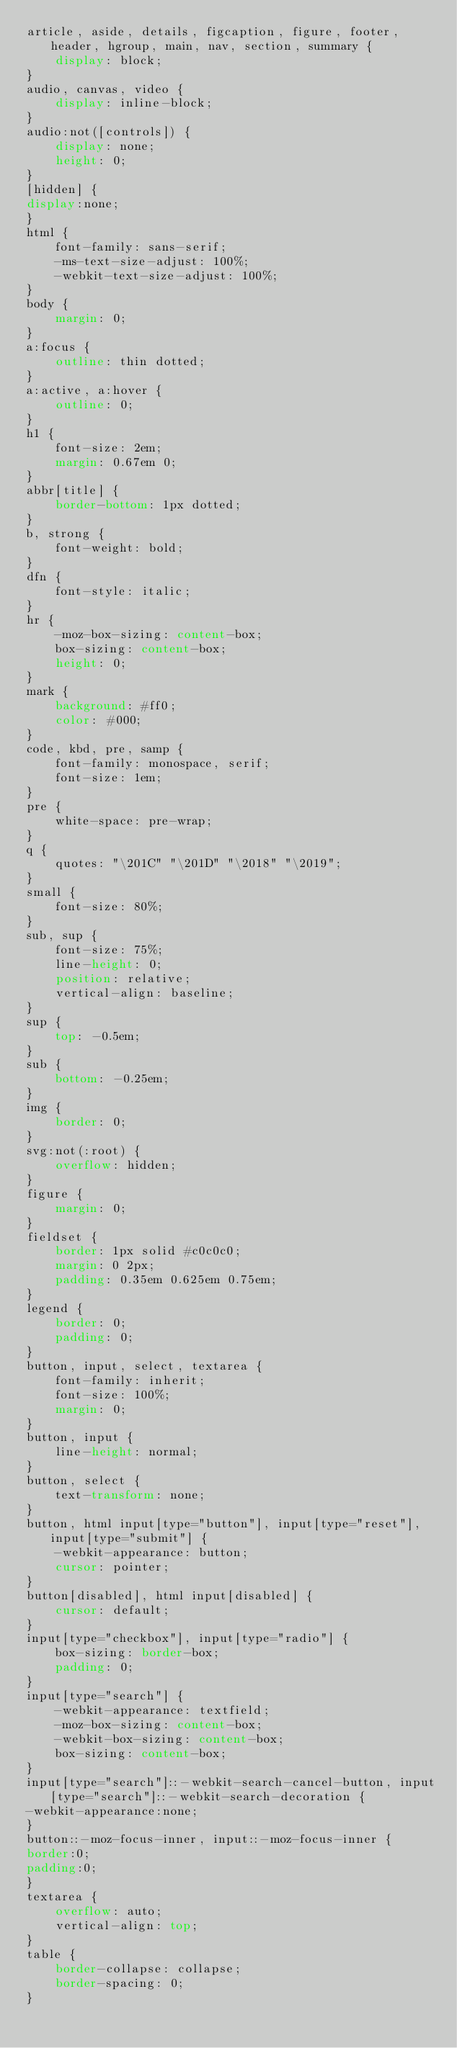Convert code to text. <code><loc_0><loc_0><loc_500><loc_500><_CSS_>article, aside, details, figcaption, figure, footer, header, hgroup, main, nav, section, summary {
	display: block;
}
audio, canvas, video {
	display: inline-block;
}
audio:not([controls]) {
	display: none;
	height: 0;
}
[hidden] {
display:none;
}
html {
	font-family: sans-serif;
	-ms-text-size-adjust: 100%;
	-webkit-text-size-adjust: 100%;
}
body {
	margin: 0;
}
a:focus {
	outline: thin dotted;
}
a:active, a:hover {
	outline: 0;
}
h1 {
	font-size: 2em;
	margin: 0.67em 0;
}
abbr[title] {
	border-bottom: 1px dotted;
}
b, strong {
	font-weight: bold;
}
dfn {
	font-style: italic;
}
hr {
	-moz-box-sizing: content-box;
	box-sizing: content-box;
	height: 0;
}
mark {
	background: #ff0;
	color: #000;
}
code, kbd, pre, samp {
	font-family: monospace, serif;
	font-size: 1em;
}
pre {
	white-space: pre-wrap;
}
q {
	quotes: "\201C" "\201D" "\2018" "\2019";
}
small {
	font-size: 80%;
}
sub, sup {
	font-size: 75%;
	line-height: 0;
	position: relative;
	vertical-align: baseline;
}
sup {
	top: -0.5em;
}
sub {
	bottom: -0.25em;
}
img {
	border: 0;
}
svg:not(:root) {
	overflow: hidden;
}
figure {
	margin: 0;
}
fieldset {
	border: 1px solid #c0c0c0;
	margin: 0 2px;
	padding: 0.35em 0.625em 0.75em;
}
legend {
	border: 0;
	padding: 0;
}
button, input, select, textarea {
	font-family: inherit;
	font-size: 100%;
	margin: 0;
}
button, input {
	line-height: normal;
}
button, select {
	text-transform: none;
}
button, html input[type="button"], input[type="reset"], input[type="submit"] {
	-webkit-appearance: button;
	cursor: pointer;
}
button[disabled], html input[disabled] {
	cursor: default;
}
input[type="checkbox"], input[type="radio"] {
	box-sizing: border-box;
	padding: 0;
}
input[type="search"] {
	-webkit-appearance: textfield;
	-moz-box-sizing: content-box;
	-webkit-box-sizing: content-box;
	box-sizing: content-box;
}
input[type="search"]::-webkit-search-cancel-button, input[type="search"]::-webkit-search-decoration {
-webkit-appearance:none;
}
button::-moz-focus-inner, input::-moz-focus-inner {
border:0;
padding:0;
}
textarea {
	overflow: auto;
	vertical-align: top;
}
table {
	border-collapse: collapse;
	border-spacing: 0;
}
</code> 